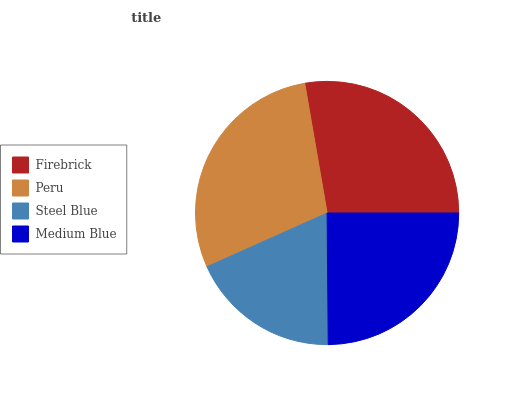Is Steel Blue the minimum?
Answer yes or no. Yes. Is Peru the maximum?
Answer yes or no. Yes. Is Peru the minimum?
Answer yes or no. No. Is Steel Blue the maximum?
Answer yes or no. No. Is Peru greater than Steel Blue?
Answer yes or no. Yes. Is Steel Blue less than Peru?
Answer yes or no. Yes. Is Steel Blue greater than Peru?
Answer yes or no. No. Is Peru less than Steel Blue?
Answer yes or no. No. Is Firebrick the high median?
Answer yes or no. Yes. Is Medium Blue the low median?
Answer yes or no. Yes. Is Medium Blue the high median?
Answer yes or no. No. Is Steel Blue the low median?
Answer yes or no. No. 